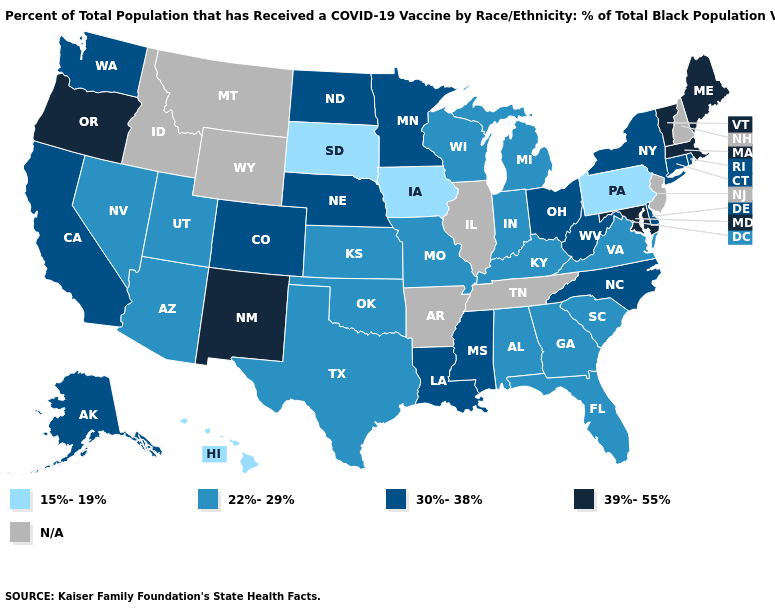Does Oregon have the highest value in the USA?
Be succinct. Yes. Name the states that have a value in the range 30%-38%?
Quick response, please. Alaska, California, Colorado, Connecticut, Delaware, Louisiana, Minnesota, Mississippi, Nebraska, New York, North Carolina, North Dakota, Ohio, Rhode Island, Washington, West Virginia. What is the highest value in the MidWest ?
Write a very short answer. 30%-38%. Name the states that have a value in the range 30%-38%?
Keep it brief. Alaska, California, Colorado, Connecticut, Delaware, Louisiana, Minnesota, Mississippi, Nebraska, New York, North Carolina, North Dakota, Ohio, Rhode Island, Washington, West Virginia. What is the lowest value in the USA?
Concise answer only. 15%-19%. What is the lowest value in the Northeast?
Be succinct. 15%-19%. Does Iowa have the highest value in the USA?
Answer briefly. No. What is the lowest value in the South?
Concise answer only. 22%-29%. Is the legend a continuous bar?
Short answer required. No. Name the states that have a value in the range N/A?
Be succinct. Arkansas, Idaho, Illinois, Montana, New Hampshire, New Jersey, Tennessee, Wyoming. Name the states that have a value in the range 15%-19%?
Short answer required. Hawaii, Iowa, Pennsylvania, South Dakota. What is the value of Arkansas?
Give a very brief answer. N/A. 